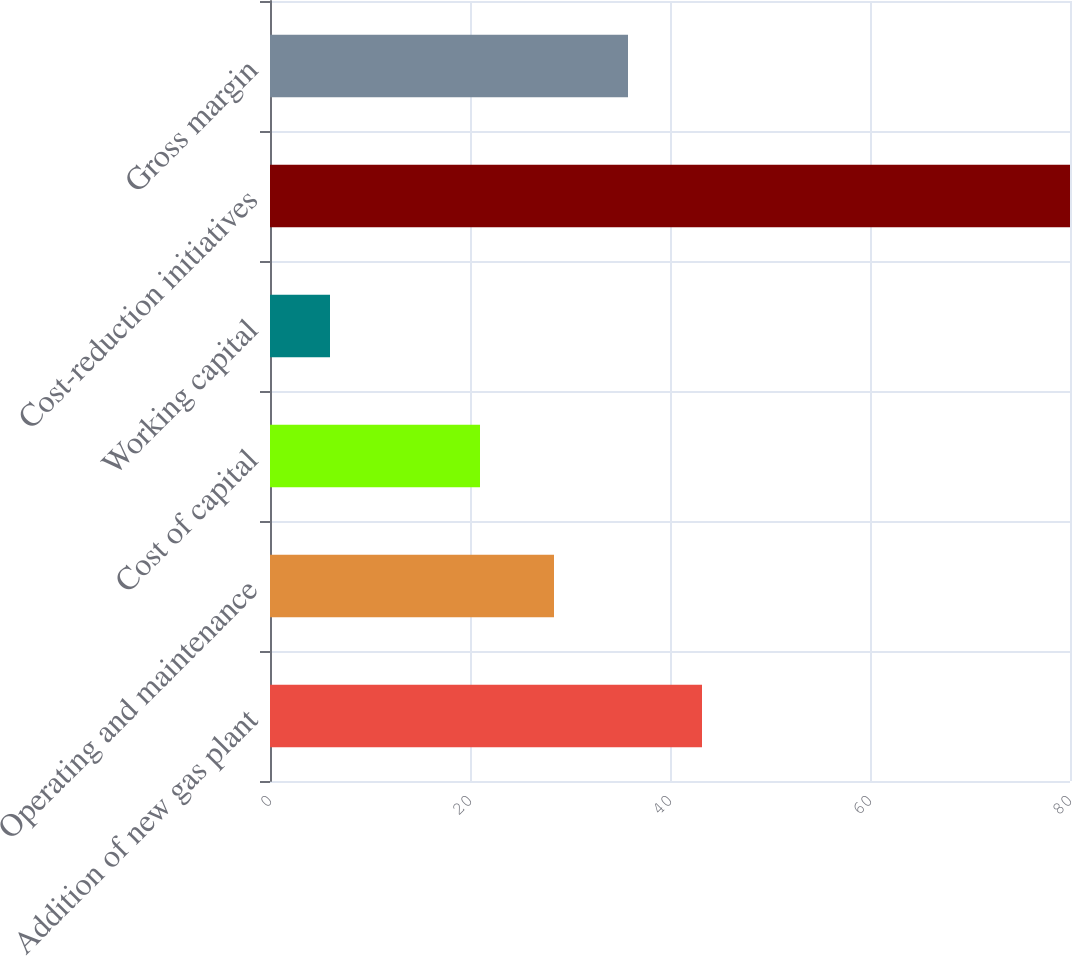Convert chart to OTSL. <chart><loc_0><loc_0><loc_500><loc_500><bar_chart><fcel>Addition of new gas plant<fcel>Operating and maintenance<fcel>Cost of capital<fcel>Working capital<fcel>Cost-reduction initiatives<fcel>Gross margin<nl><fcel>43.2<fcel>28.4<fcel>21<fcel>6<fcel>80<fcel>35.8<nl></chart> 